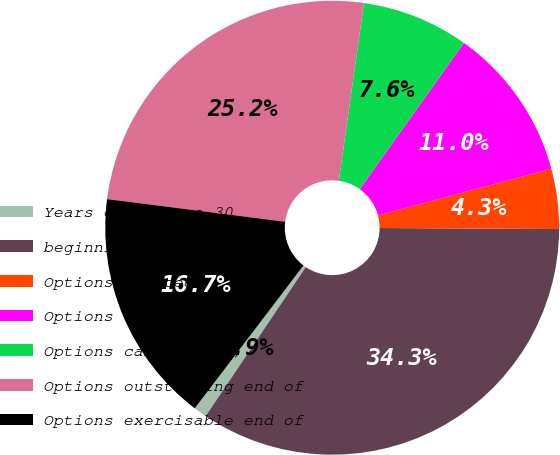Convert chart. <chart><loc_0><loc_0><loc_500><loc_500><pie_chart><fcel>Years ended June 30<fcel>beginning of year<fcel>Options granted<fcel>Options exercised<fcel>Options canceled (a)<fcel>Options outstanding end of<fcel>Options exercisable end of<nl><fcel>0.94%<fcel>34.32%<fcel>4.28%<fcel>10.96%<fcel>7.62%<fcel>25.22%<fcel>16.66%<nl></chart> 